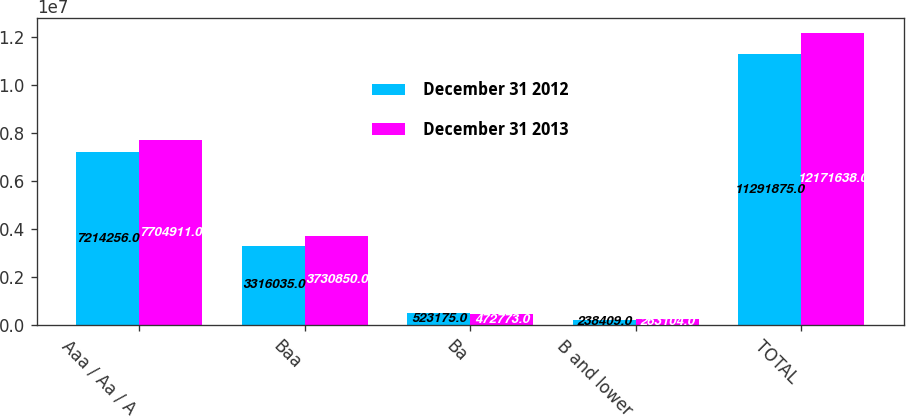Convert chart. <chart><loc_0><loc_0><loc_500><loc_500><stacked_bar_chart><ecel><fcel>Aaa / Aa / A<fcel>Baa<fcel>Ba<fcel>B and lower<fcel>TOTAL<nl><fcel>December 31 2012<fcel>7.21426e+06<fcel>3.31604e+06<fcel>523175<fcel>238409<fcel>1.12919e+07<nl><fcel>December 31 2013<fcel>7.70491e+06<fcel>3.73085e+06<fcel>472773<fcel>263104<fcel>1.21716e+07<nl></chart> 